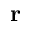Convert formula to latex. <formula><loc_0><loc_0><loc_500><loc_500>r</formula> 